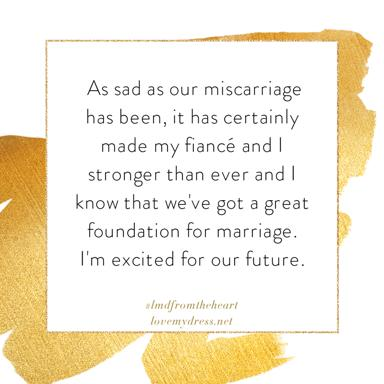What is the design of the image? The image features an elegant design with a gold frame that encircles a white square center. The text is thoughtfully placed within this square, effectively drawing attention. The gold splashes suggest a sense of preciousness and the resilience to shine despite challenges. 